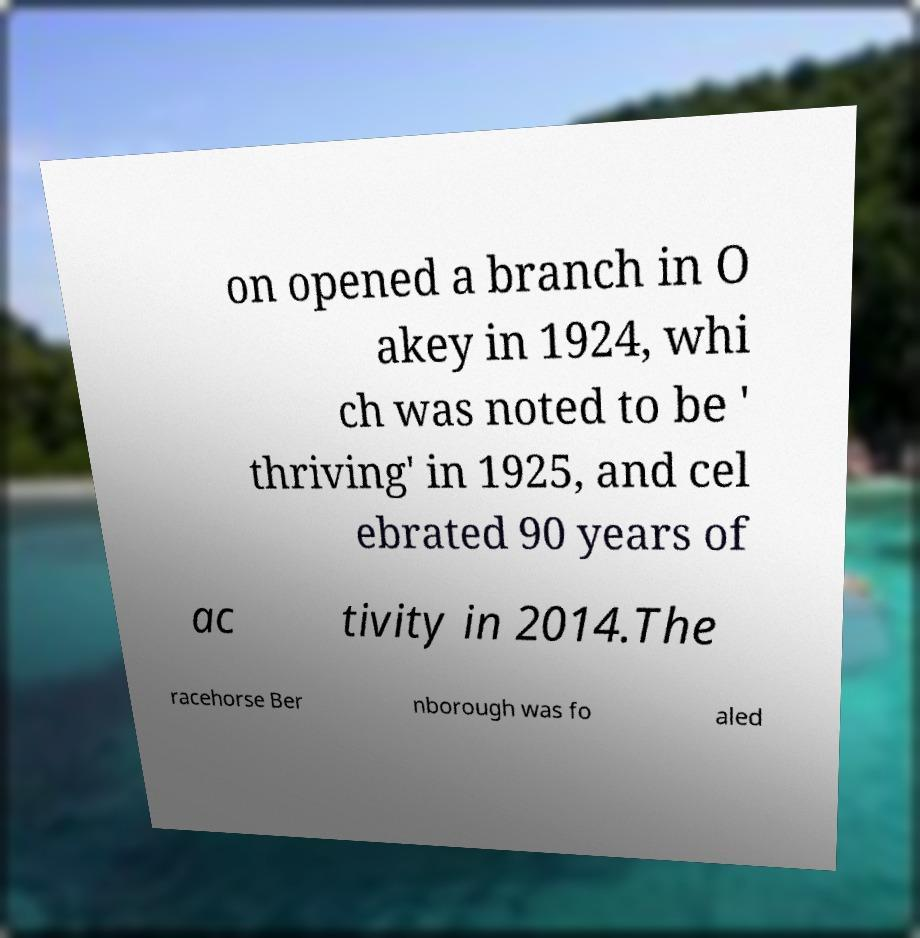Can you accurately transcribe the text from the provided image for me? on opened a branch in O akey in 1924, whi ch was noted to be ' thriving' in 1925, and cel ebrated 90 years of ac tivity in 2014.The racehorse Ber nborough was fo aled 